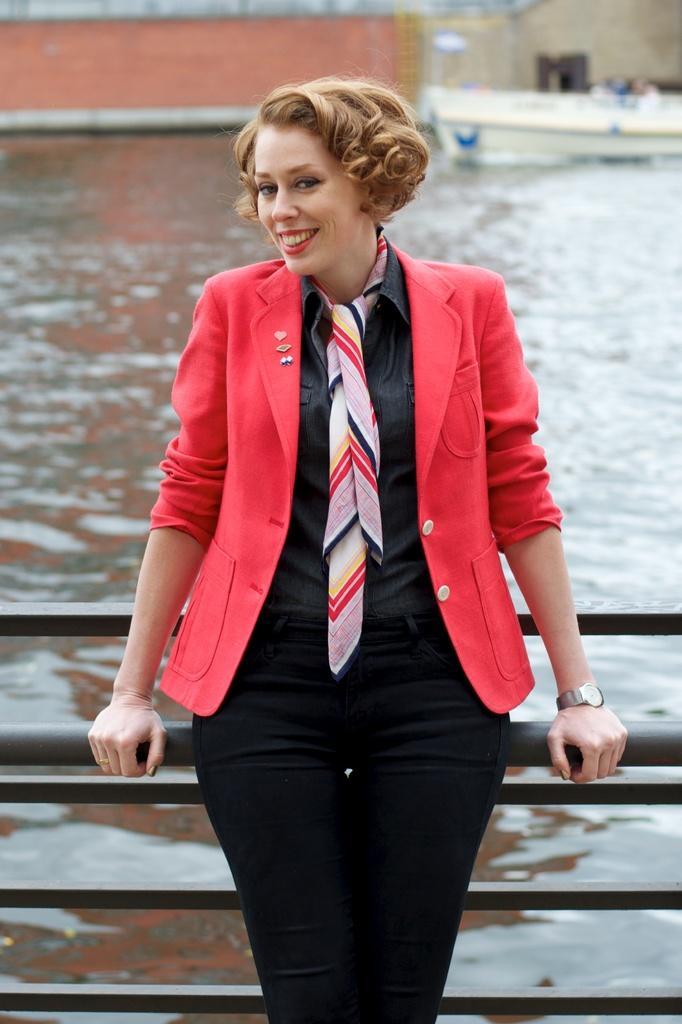Please provide a concise description of this image. In this image, we can see a woman is watching and smiling. She is holding a rod. Background there is a blur view. Here we can see rods, water, boat and walls. 